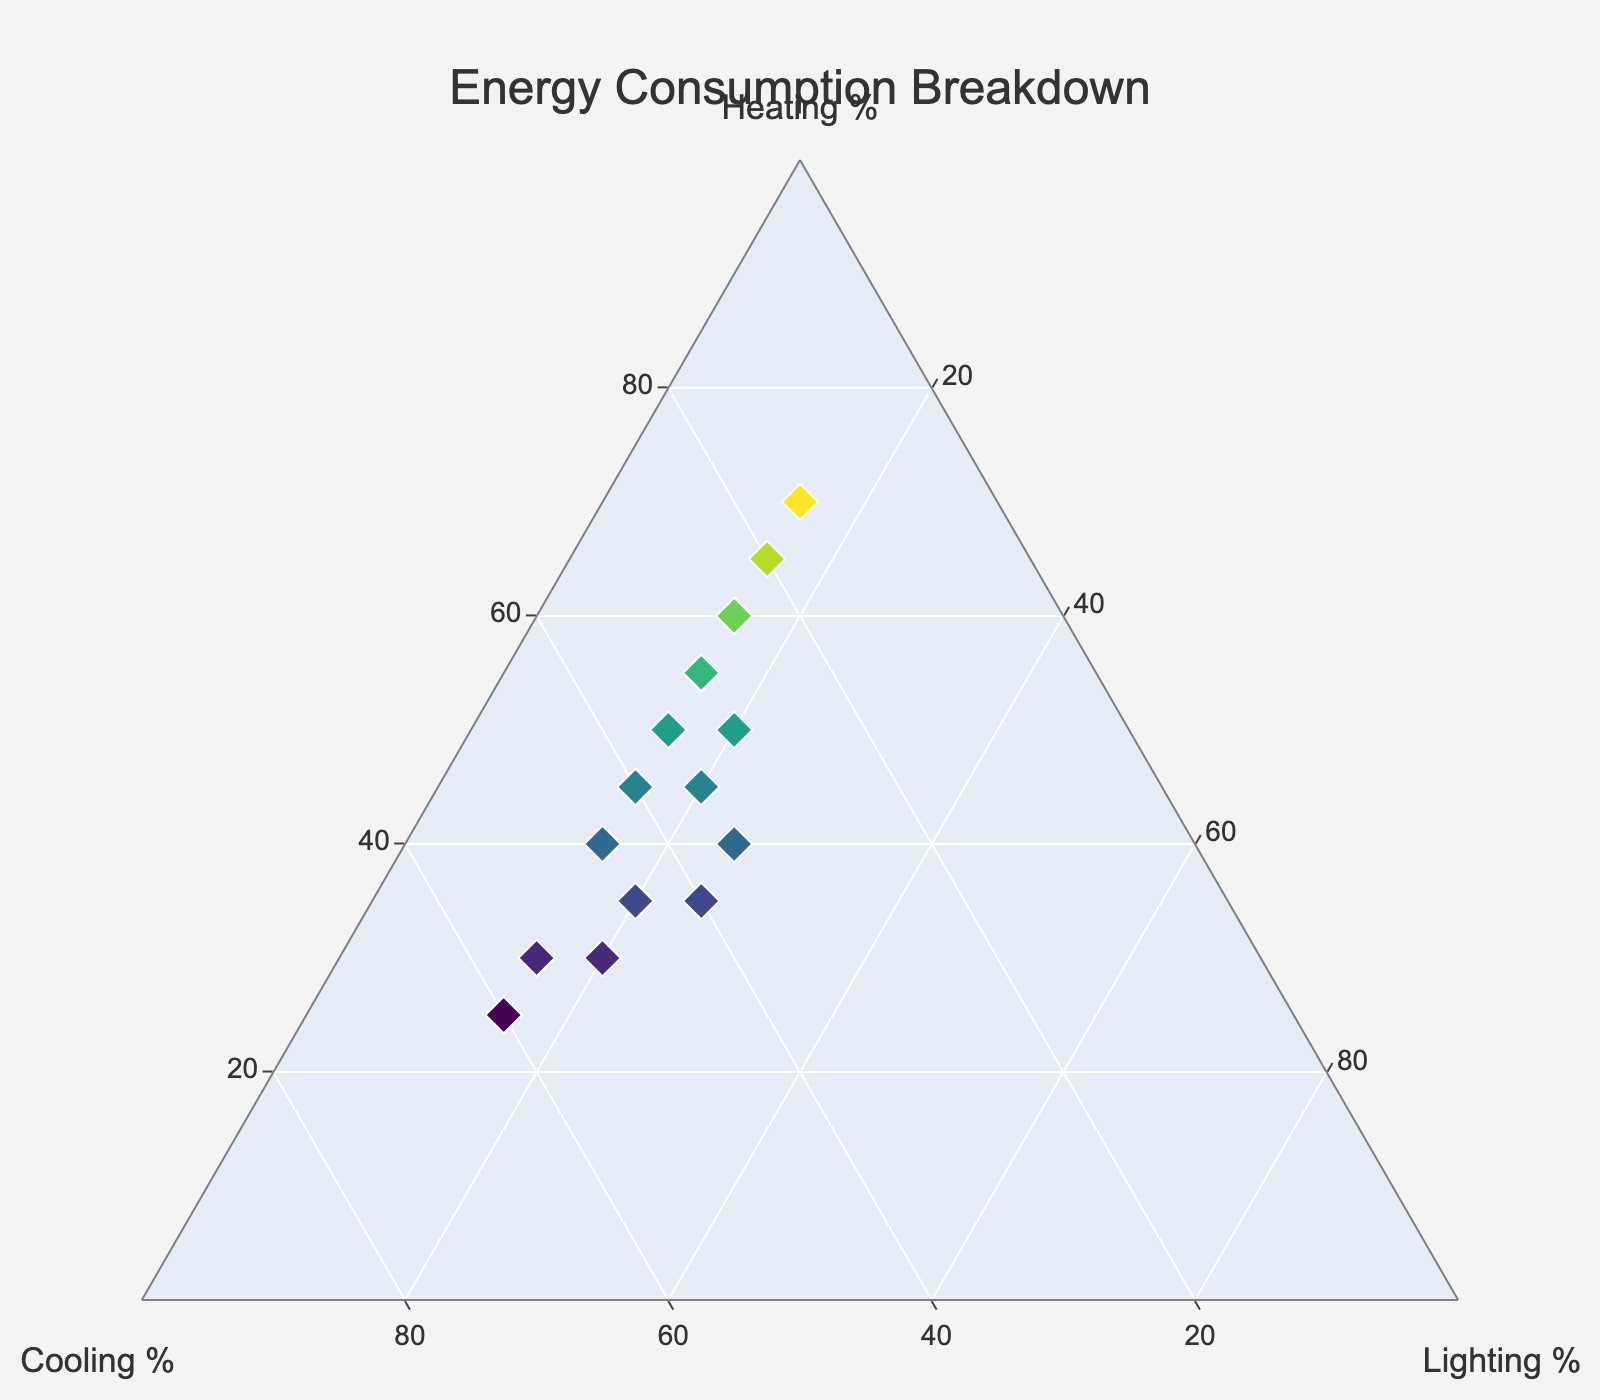How many data points are plotted in the figure? By counting the number of markers on the Ternary Plot, we see that there are 15 markers, one for each row of data provided.
Answer: 15 What is the title of the Ternary Plot? The title is displayed prominently at the top center of the plot.
Answer: Energy Consumption Breakdown Which axis represents the Heating percentage? The 'a' axis on the Ternary Plot is labeled as 'Heating %'.
Answer: a-axis What's the range of Heating percentages in the dataset? By looking at the values on the Heating axis, the minimum value is 25% and the maximum is 70%.
Answer: 25% to 70% Compare the heating percentage of data points 1 and 4, which is higher? Data point 1 has a heating percentage of 45%, and data point 4 has 35%, so 45% is higher.
Answer: Data point 1 Which data point has the highest cooling percentage? The data point with the highest cooling percentage is where the value is 60%, which corresponds to data point 14.
Answer: Data point 14 What is the sum of the Heating and Cooling percentages for data point 6? Data point 6 has a Heating percentage of 40% and Cooling percentage of 35%, so the sum is 40% + 35% = 75%.
Answer: 75% What's the average percentage for lighting across all data points? Lighting percentages are 15, 15, 15, 20, 15, 25, 15, 20, 20, 15, 25, 15, 20, 15, 15. Summing these gives 255. Dividing by 15 data points results in an average of 255/15 = 17%.
Answer: 17% In which region (more towards Heating, Cooling, or Lighting) do most data points fall? By analyzing the clustering of points, most data points are closer to the Heating and Cooling axes rather than the Lighting axis.
Answer: Heating/Cooling Are there any data points where the percentages of Heating and Cooling are equal? By checking all data points, none have equal percentages for Heating and Cooling.
Answer: No 